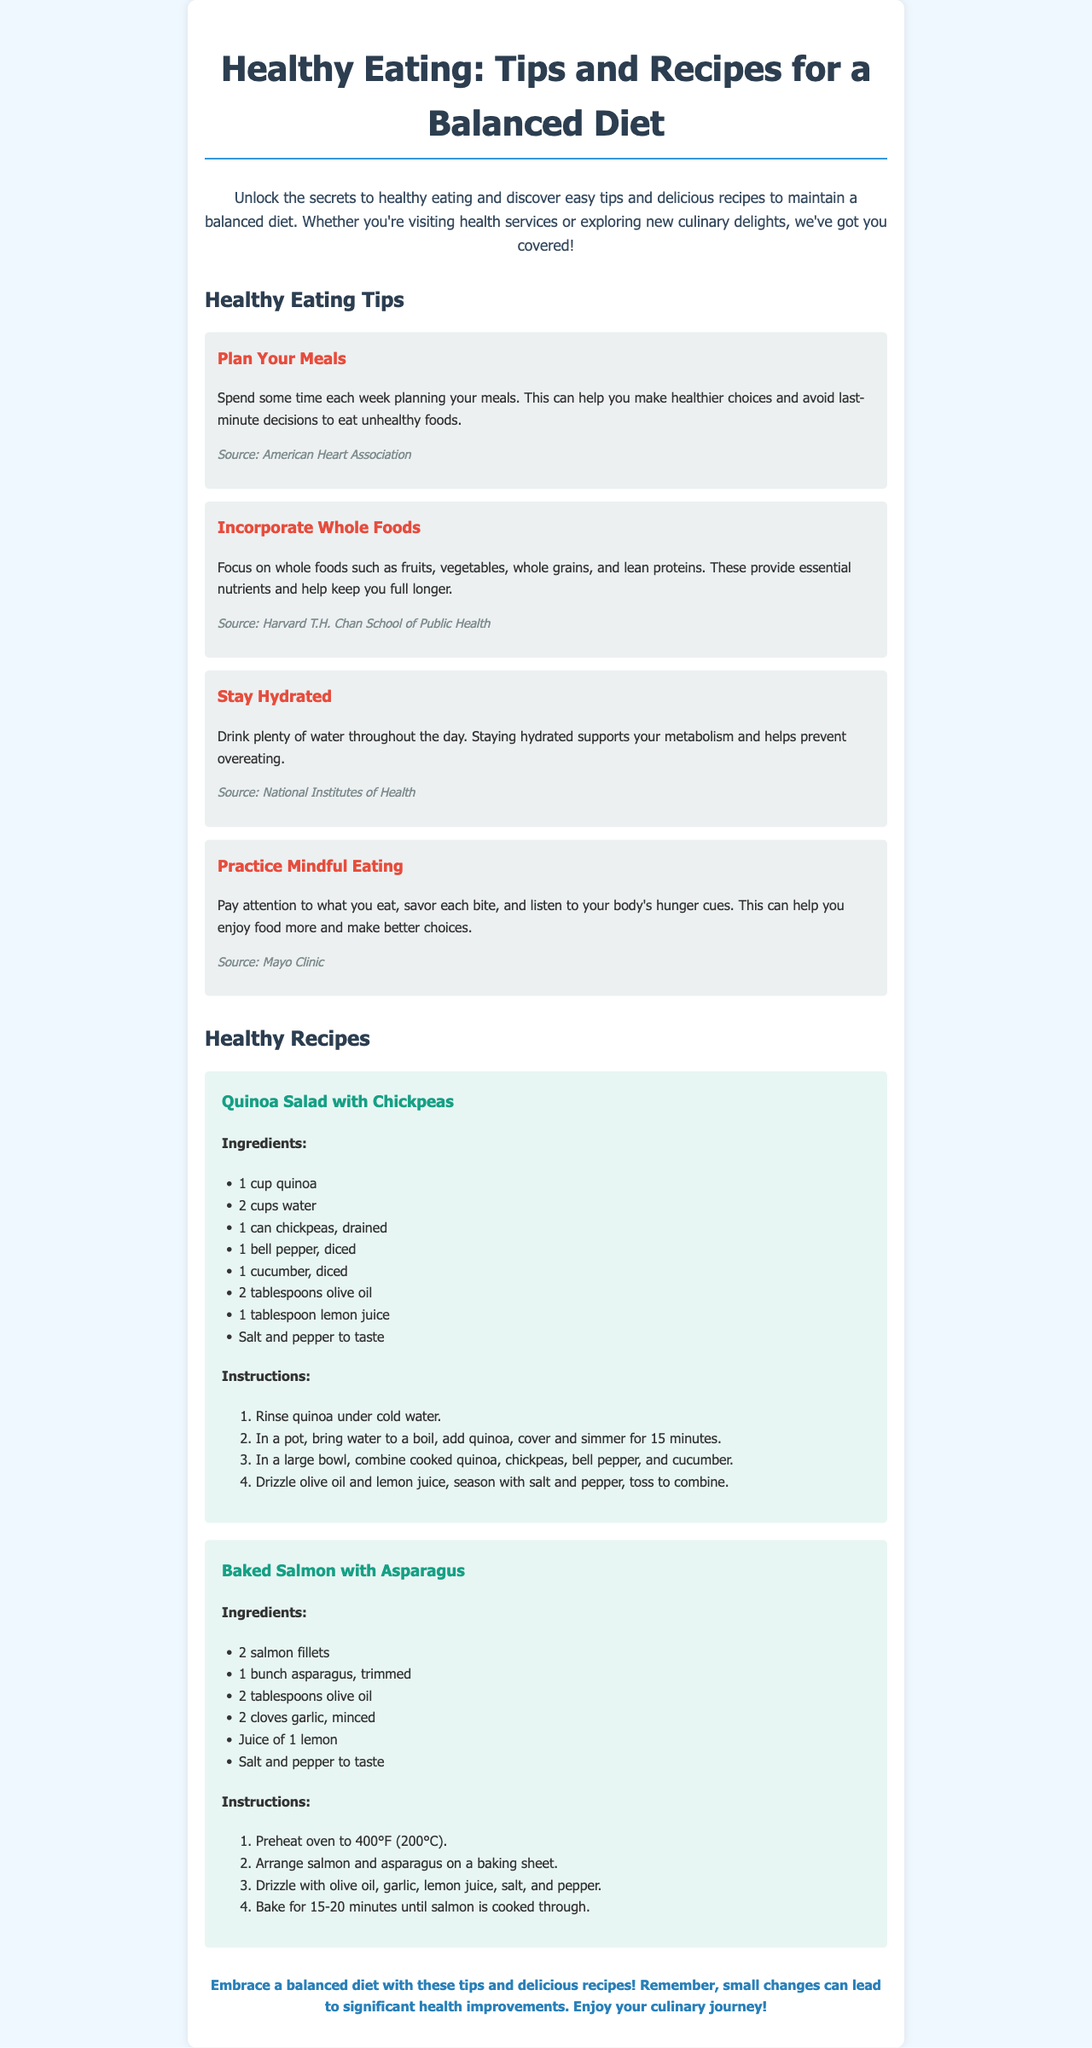What is the title of the newsletter? The title of the newsletter is displayed prominently at the top of the document.
Answer: Healthy Eating: Tips and Recipes for a Balanced Diet How many healthy eating tips are provided? The number of tips can be counted in the section dedicated to healthy eating tips.
Answer: Four What is one source cited for the tip to incorporate whole foods? The specific source for the tip is mentioned directly under the respective tip.
Answer: Harvard T.H. Chan School of Public Health What ingredient is used in both recipes? The ingredient can be found in the ingredients list of both recipes provided in the document.
Answer: Olive oil What cooking method is used for the salmon recipe? The cooking method is stated in the instructions for preparing the salmon dish.
Answer: Baked What is the first step in making the quinoa salad? The first step is listed in the instructions of the quinoa salad recipe.
Answer: Rinse quinoa under cold water Which tip encourages paying attention to hunger signals? The tip that covers this subject can be identified from the section outlining healthy eating tips.
Answer: Practice Mindful Eating How long should the salmon be baked? The duration for baking the salmon is specified in the recipe's instructions.
Answer: 15-20 minutes 